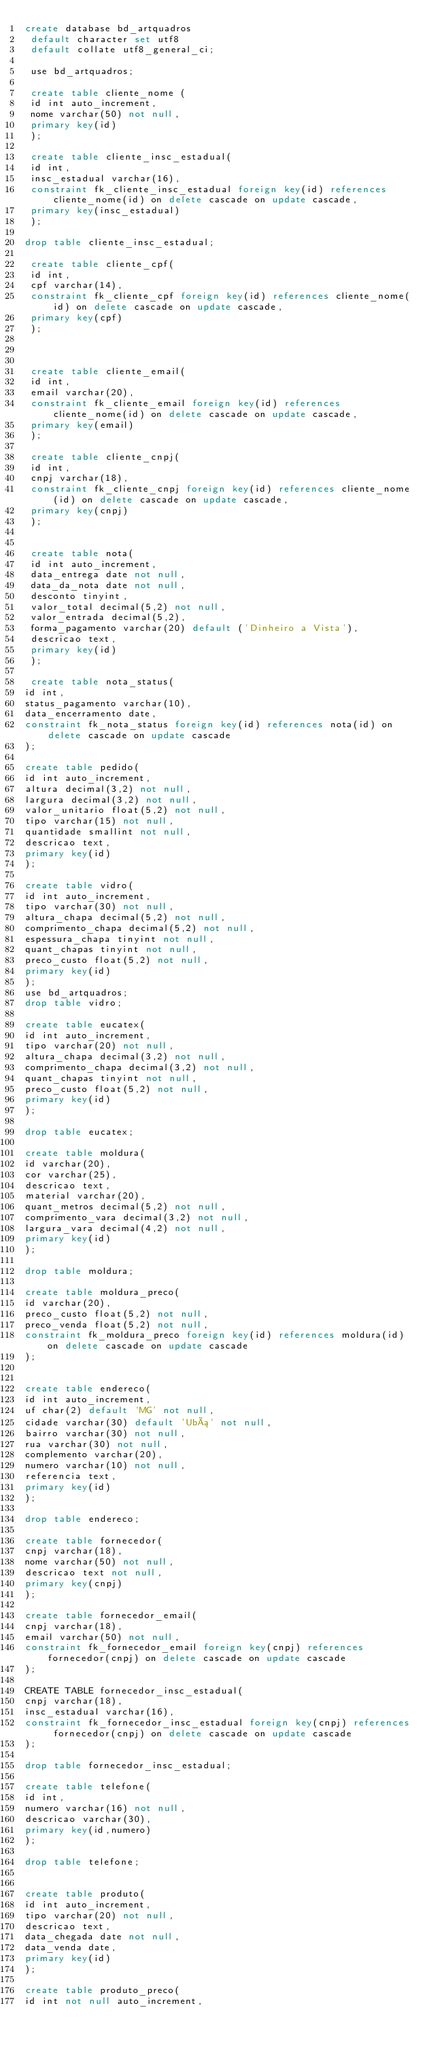Convert code to text. <code><loc_0><loc_0><loc_500><loc_500><_SQL_>create database bd_artquadros
 default character set utf8 
 default collate utf8_general_ci;
 
 use bd_artquadros;
 
 create table cliente_nome (
 id int auto_increment,
 nome varchar(50) not null,
 primary key(id)
 );
  
 create table cliente_insc_estadual(
 id int,
 insc_estadual varchar(16),
 constraint fk_cliente_insc_estadual foreign key(id) references cliente_nome(id) on delete cascade on update cascade,
 primary key(insc_estadual)
 );

drop table cliente_insc_estadual;
 
 create table cliente_cpf(
 id int,
 cpf varchar(14),
 constraint fk_cliente_cpf foreign key(id) references cliente_nome(id) on delete cascade on update cascade,
 primary key(cpf)
 );
 

 
 create table cliente_email(
 id int,
 email varchar(20),
 constraint fk_cliente_email foreign key(id) references cliente_nome(id) on delete cascade on update cascade,
 primary key(email)
 );
  
 create table cliente_cnpj(
 id int,
 cnpj varchar(18),
 constraint fk_cliente_cnpj foreign key(id) references cliente_nome(id) on delete cascade on update cascade,
 primary key(cnpj)
 );
 

 create table nota(
 id int auto_increment,
 data_entrega date not null,
 data_da_nota date not null,
 desconto tinyint,
 valor_total decimal(5,2) not null,
 valor_entrada decimal(5,2),
 forma_pagamento varchar(20) default ('Dinheiro a Vista'),
 descricao text,
 primary key(id)
 );
 
 create table nota_status(
id int,
status_pagamento varchar(10),
data_encerramento date,
constraint fk_nota_status foreign key(id) references nota(id) on delete cascade on update cascade
);
 
create table pedido(
id int auto_increment,
altura decimal(3,2) not null,
largura decimal(3,2) not null,
valor_unitario float(5,2) not null,
tipo varchar(15) not null,
quantidade smallint not null,
descricao text,
primary key(id)
);

create table vidro(
id int auto_increment,
tipo varchar(30) not null,
altura_chapa decimal(5,2) not null,
comprimento_chapa decimal(5,2) not null,
espessura_chapa tinyint not null,
quant_chapas tinyint not null,
preco_custo float(5,2) not null,
primary key(id)
);
use bd_artquadros;
drop table vidro;

create table eucatex(
id int auto_increment,
tipo varchar(20) not null,
altura_chapa decimal(3,2) not null,
comprimento_chapa decimal(3,2) not null,
quant_chapas tinyint not null,
preco_custo float(5,2) not null,
primary key(id)
);

drop table eucatex;

create table moldura(
id varchar(20),
cor varchar(25),
descricao text,
material varchar(20),
quant_metros decimal(5,2) not null,
comprimento_vara decimal(3,2) not null,
largura_vara decimal(4,2) not null,
primary key(id)
);

drop table moldura;

create table moldura_preco(
id varchar(20),
preco_custo float(5,2) not null,
preco_venda float(5,2) not null,
constraint fk_moldura_preco foreign key(id) references moldura(id) on delete cascade on update cascade
);


create table endereco(
id int auto_increment,
uf char(2) default 'MG' not null,
cidade varchar(30) default 'Ubá' not null,
bairro varchar(30) not null,
rua varchar(30) not null,
complemento varchar(20),
numero varchar(10) not null,
referencia text,
primary key(id)
);

drop table endereco;

create table fornecedor(
cnpj varchar(18),
nome varchar(50) not null,
descricao text not null,
primary key(cnpj)
);

create table fornecedor_email(
cnpj varchar(18),
email varchar(50) not null,
constraint fk_fornecedor_email foreign key(cnpj) references fornecedor(cnpj) on delete cascade on update cascade
);

CREATE TABLE fornecedor_insc_estadual(
cnpj varchar(18),
insc_estadual varchar(16),
constraint fk_fornecedor_insc_estadual foreign key(cnpj) references fornecedor(cnpj) on delete cascade on update cascade
);

drop table fornecedor_insc_estadual;

create table telefone(
id int,
numero varchar(16) not null,
descricao varchar(30),
primary key(id,numero)
);

drop table telefone;


create table produto(
id int auto_increment,
tipo varchar(20) not null,
descricao text,
data_chegada date not null,
data_venda date,
primary key(id)
);

create table produto_preco(
id int not null auto_increment,</code> 